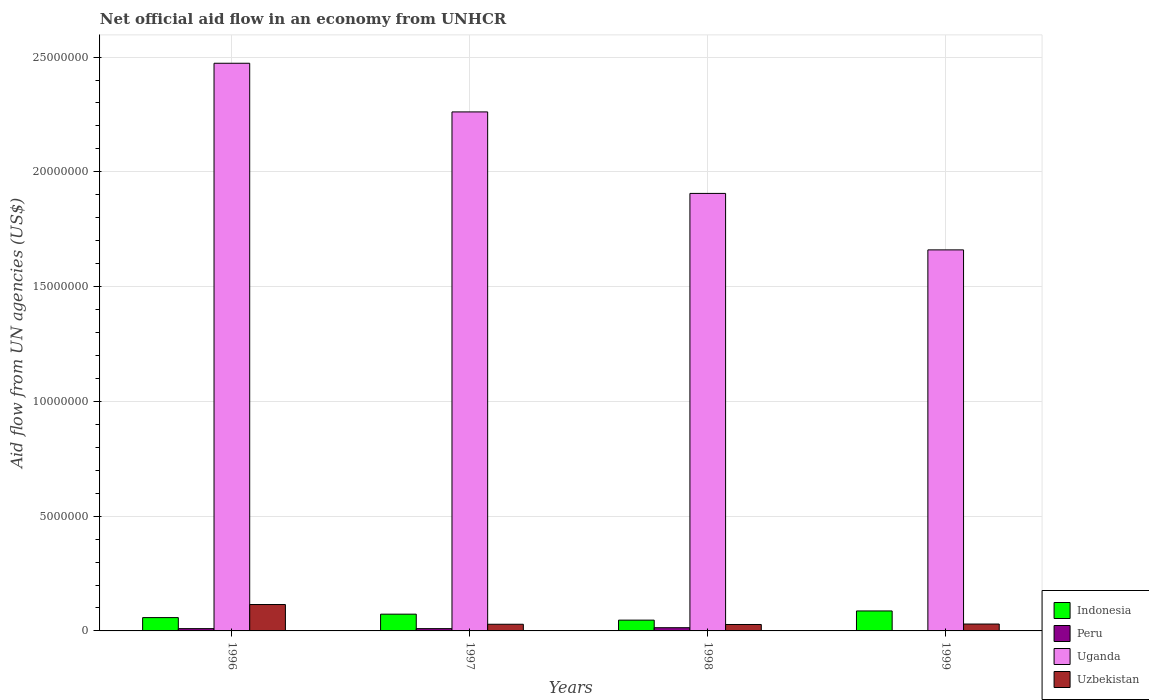How many different coloured bars are there?
Your answer should be compact. 4. How many groups of bars are there?
Your response must be concise. 4. Are the number of bars per tick equal to the number of legend labels?
Ensure brevity in your answer.  Yes. Are the number of bars on each tick of the X-axis equal?
Provide a succinct answer. Yes. How many bars are there on the 4th tick from the right?
Offer a terse response. 4. What is the net official aid flow in Uzbekistan in 1997?
Make the answer very short. 2.90e+05. Across all years, what is the minimum net official aid flow in Indonesia?
Offer a very short reply. 4.70e+05. In which year was the net official aid flow in Peru minimum?
Provide a short and direct response. 1999. What is the difference between the net official aid flow in Uzbekistan in 1996 and that in 1997?
Offer a very short reply. 8.60e+05. What is the difference between the net official aid flow in Peru in 1997 and the net official aid flow in Indonesia in 1996?
Make the answer very short. -4.80e+05. What is the average net official aid flow in Indonesia per year?
Make the answer very short. 6.62e+05. In the year 1997, what is the difference between the net official aid flow in Uzbekistan and net official aid flow in Indonesia?
Give a very brief answer. -4.40e+05. In how many years, is the net official aid flow in Uganda greater than 6000000 US$?
Provide a short and direct response. 4. What is the ratio of the net official aid flow in Indonesia in 1996 to that in 1998?
Make the answer very short. 1.23. Is the net official aid flow in Uzbekistan in 1996 less than that in 1998?
Offer a very short reply. No. Is the difference between the net official aid flow in Uzbekistan in 1997 and 1999 greater than the difference between the net official aid flow in Indonesia in 1997 and 1999?
Offer a very short reply. Yes. What is the difference between the highest and the second highest net official aid flow in Uzbekistan?
Make the answer very short. 8.50e+05. In how many years, is the net official aid flow in Uzbekistan greater than the average net official aid flow in Uzbekistan taken over all years?
Give a very brief answer. 1. Is the sum of the net official aid flow in Uzbekistan in 1996 and 1997 greater than the maximum net official aid flow in Peru across all years?
Provide a short and direct response. Yes. What does the 4th bar from the left in 1997 represents?
Make the answer very short. Uzbekistan. What does the 1st bar from the right in 1996 represents?
Give a very brief answer. Uzbekistan. Is it the case that in every year, the sum of the net official aid flow in Uganda and net official aid flow in Uzbekistan is greater than the net official aid flow in Indonesia?
Make the answer very short. Yes. Does the graph contain grids?
Provide a succinct answer. Yes. How are the legend labels stacked?
Offer a very short reply. Vertical. What is the title of the graph?
Your response must be concise. Net official aid flow in an economy from UNHCR. Does "Niger" appear as one of the legend labels in the graph?
Give a very brief answer. No. What is the label or title of the X-axis?
Your response must be concise. Years. What is the label or title of the Y-axis?
Give a very brief answer. Aid flow from UN agencies (US$). What is the Aid flow from UN agencies (US$) of Indonesia in 1996?
Provide a succinct answer. 5.80e+05. What is the Aid flow from UN agencies (US$) of Peru in 1996?
Keep it short and to the point. 1.00e+05. What is the Aid flow from UN agencies (US$) in Uganda in 1996?
Give a very brief answer. 2.47e+07. What is the Aid flow from UN agencies (US$) in Uzbekistan in 1996?
Keep it short and to the point. 1.15e+06. What is the Aid flow from UN agencies (US$) of Indonesia in 1997?
Keep it short and to the point. 7.30e+05. What is the Aid flow from UN agencies (US$) in Uganda in 1997?
Your answer should be very brief. 2.26e+07. What is the Aid flow from UN agencies (US$) of Uzbekistan in 1997?
Provide a short and direct response. 2.90e+05. What is the Aid flow from UN agencies (US$) of Uganda in 1998?
Ensure brevity in your answer.  1.91e+07. What is the Aid flow from UN agencies (US$) of Uzbekistan in 1998?
Give a very brief answer. 2.80e+05. What is the Aid flow from UN agencies (US$) of Indonesia in 1999?
Provide a succinct answer. 8.70e+05. What is the Aid flow from UN agencies (US$) in Peru in 1999?
Provide a succinct answer. 10000. What is the Aid flow from UN agencies (US$) in Uganda in 1999?
Give a very brief answer. 1.66e+07. Across all years, what is the maximum Aid flow from UN agencies (US$) of Indonesia?
Make the answer very short. 8.70e+05. Across all years, what is the maximum Aid flow from UN agencies (US$) of Peru?
Give a very brief answer. 1.40e+05. Across all years, what is the maximum Aid flow from UN agencies (US$) of Uganda?
Provide a succinct answer. 2.47e+07. Across all years, what is the maximum Aid flow from UN agencies (US$) in Uzbekistan?
Provide a short and direct response. 1.15e+06. Across all years, what is the minimum Aid flow from UN agencies (US$) in Indonesia?
Your response must be concise. 4.70e+05. Across all years, what is the minimum Aid flow from UN agencies (US$) in Peru?
Offer a very short reply. 10000. Across all years, what is the minimum Aid flow from UN agencies (US$) of Uganda?
Your response must be concise. 1.66e+07. What is the total Aid flow from UN agencies (US$) in Indonesia in the graph?
Keep it short and to the point. 2.65e+06. What is the total Aid flow from UN agencies (US$) in Peru in the graph?
Make the answer very short. 3.50e+05. What is the total Aid flow from UN agencies (US$) in Uganda in the graph?
Your answer should be compact. 8.30e+07. What is the total Aid flow from UN agencies (US$) in Uzbekistan in the graph?
Keep it short and to the point. 2.02e+06. What is the difference between the Aid flow from UN agencies (US$) in Peru in 1996 and that in 1997?
Give a very brief answer. 0. What is the difference between the Aid flow from UN agencies (US$) of Uganda in 1996 and that in 1997?
Your answer should be very brief. 2.12e+06. What is the difference between the Aid flow from UN agencies (US$) in Uzbekistan in 1996 and that in 1997?
Offer a terse response. 8.60e+05. What is the difference between the Aid flow from UN agencies (US$) of Uganda in 1996 and that in 1998?
Keep it short and to the point. 5.67e+06. What is the difference between the Aid flow from UN agencies (US$) of Uzbekistan in 1996 and that in 1998?
Give a very brief answer. 8.70e+05. What is the difference between the Aid flow from UN agencies (US$) of Uganda in 1996 and that in 1999?
Your answer should be very brief. 8.13e+06. What is the difference between the Aid flow from UN agencies (US$) of Uzbekistan in 1996 and that in 1999?
Keep it short and to the point. 8.50e+05. What is the difference between the Aid flow from UN agencies (US$) of Indonesia in 1997 and that in 1998?
Your answer should be very brief. 2.60e+05. What is the difference between the Aid flow from UN agencies (US$) in Peru in 1997 and that in 1998?
Your response must be concise. -4.00e+04. What is the difference between the Aid flow from UN agencies (US$) of Uganda in 1997 and that in 1998?
Your response must be concise. 3.55e+06. What is the difference between the Aid flow from UN agencies (US$) in Peru in 1997 and that in 1999?
Make the answer very short. 9.00e+04. What is the difference between the Aid flow from UN agencies (US$) of Uganda in 1997 and that in 1999?
Provide a short and direct response. 6.01e+06. What is the difference between the Aid flow from UN agencies (US$) of Uzbekistan in 1997 and that in 1999?
Your answer should be compact. -10000. What is the difference between the Aid flow from UN agencies (US$) in Indonesia in 1998 and that in 1999?
Your answer should be very brief. -4.00e+05. What is the difference between the Aid flow from UN agencies (US$) of Peru in 1998 and that in 1999?
Ensure brevity in your answer.  1.30e+05. What is the difference between the Aid flow from UN agencies (US$) in Uganda in 1998 and that in 1999?
Your answer should be compact. 2.46e+06. What is the difference between the Aid flow from UN agencies (US$) in Indonesia in 1996 and the Aid flow from UN agencies (US$) in Peru in 1997?
Provide a succinct answer. 4.80e+05. What is the difference between the Aid flow from UN agencies (US$) in Indonesia in 1996 and the Aid flow from UN agencies (US$) in Uganda in 1997?
Ensure brevity in your answer.  -2.20e+07. What is the difference between the Aid flow from UN agencies (US$) in Peru in 1996 and the Aid flow from UN agencies (US$) in Uganda in 1997?
Offer a terse response. -2.25e+07. What is the difference between the Aid flow from UN agencies (US$) in Uganda in 1996 and the Aid flow from UN agencies (US$) in Uzbekistan in 1997?
Keep it short and to the point. 2.44e+07. What is the difference between the Aid flow from UN agencies (US$) of Indonesia in 1996 and the Aid flow from UN agencies (US$) of Peru in 1998?
Offer a very short reply. 4.40e+05. What is the difference between the Aid flow from UN agencies (US$) in Indonesia in 1996 and the Aid flow from UN agencies (US$) in Uganda in 1998?
Give a very brief answer. -1.85e+07. What is the difference between the Aid flow from UN agencies (US$) in Indonesia in 1996 and the Aid flow from UN agencies (US$) in Uzbekistan in 1998?
Your answer should be compact. 3.00e+05. What is the difference between the Aid flow from UN agencies (US$) of Peru in 1996 and the Aid flow from UN agencies (US$) of Uganda in 1998?
Provide a short and direct response. -1.90e+07. What is the difference between the Aid flow from UN agencies (US$) of Uganda in 1996 and the Aid flow from UN agencies (US$) of Uzbekistan in 1998?
Offer a terse response. 2.44e+07. What is the difference between the Aid flow from UN agencies (US$) in Indonesia in 1996 and the Aid flow from UN agencies (US$) in Peru in 1999?
Provide a succinct answer. 5.70e+05. What is the difference between the Aid flow from UN agencies (US$) of Indonesia in 1996 and the Aid flow from UN agencies (US$) of Uganda in 1999?
Offer a very short reply. -1.60e+07. What is the difference between the Aid flow from UN agencies (US$) in Indonesia in 1996 and the Aid flow from UN agencies (US$) in Uzbekistan in 1999?
Ensure brevity in your answer.  2.80e+05. What is the difference between the Aid flow from UN agencies (US$) of Peru in 1996 and the Aid flow from UN agencies (US$) of Uganda in 1999?
Offer a very short reply. -1.65e+07. What is the difference between the Aid flow from UN agencies (US$) of Uganda in 1996 and the Aid flow from UN agencies (US$) of Uzbekistan in 1999?
Make the answer very short. 2.44e+07. What is the difference between the Aid flow from UN agencies (US$) in Indonesia in 1997 and the Aid flow from UN agencies (US$) in Peru in 1998?
Your answer should be compact. 5.90e+05. What is the difference between the Aid flow from UN agencies (US$) of Indonesia in 1997 and the Aid flow from UN agencies (US$) of Uganda in 1998?
Your answer should be very brief. -1.83e+07. What is the difference between the Aid flow from UN agencies (US$) of Peru in 1997 and the Aid flow from UN agencies (US$) of Uganda in 1998?
Offer a terse response. -1.90e+07. What is the difference between the Aid flow from UN agencies (US$) in Uganda in 1997 and the Aid flow from UN agencies (US$) in Uzbekistan in 1998?
Keep it short and to the point. 2.23e+07. What is the difference between the Aid flow from UN agencies (US$) in Indonesia in 1997 and the Aid flow from UN agencies (US$) in Peru in 1999?
Offer a very short reply. 7.20e+05. What is the difference between the Aid flow from UN agencies (US$) in Indonesia in 1997 and the Aid flow from UN agencies (US$) in Uganda in 1999?
Provide a short and direct response. -1.59e+07. What is the difference between the Aid flow from UN agencies (US$) in Indonesia in 1997 and the Aid flow from UN agencies (US$) in Uzbekistan in 1999?
Your answer should be very brief. 4.30e+05. What is the difference between the Aid flow from UN agencies (US$) of Peru in 1997 and the Aid flow from UN agencies (US$) of Uganda in 1999?
Provide a succinct answer. -1.65e+07. What is the difference between the Aid flow from UN agencies (US$) of Uganda in 1997 and the Aid flow from UN agencies (US$) of Uzbekistan in 1999?
Give a very brief answer. 2.23e+07. What is the difference between the Aid flow from UN agencies (US$) of Indonesia in 1998 and the Aid flow from UN agencies (US$) of Peru in 1999?
Offer a very short reply. 4.60e+05. What is the difference between the Aid flow from UN agencies (US$) in Indonesia in 1998 and the Aid flow from UN agencies (US$) in Uganda in 1999?
Your response must be concise. -1.61e+07. What is the difference between the Aid flow from UN agencies (US$) in Indonesia in 1998 and the Aid flow from UN agencies (US$) in Uzbekistan in 1999?
Ensure brevity in your answer.  1.70e+05. What is the difference between the Aid flow from UN agencies (US$) of Peru in 1998 and the Aid flow from UN agencies (US$) of Uganda in 1999?
Offer a very short reply. -1.65e+07. What is the difference between the Aid flow from UN agencies (US$) in Uganda in 1998 and the Aid flow from UN agencies (US$) in Uzbekistan in 1999?
Offer a very short reply. 1.88e+07. What is the average Aid flow from UN agencies (US$) of Indonesia per year?
Keep it short and to the point. 6.62e+05. What is the average Aid flow from UN agencies (US$) of Peru per year?
Make the answer very short. 8.75e+04. What is the average Aid flow from UN agencies (US$) in Uganda per year?
Ensure brevity in your answer.  2.08e+07. What is the average Aid flow from UN agencies (US$) in Uzbekistan per year?
Provide a succinct answer. 5.05e+05. In the year 1996, what is the difference between the Aid flow from UN agencies (US$) in Indonesia and Aid flow from UN agencies (US$) in Uganda?
Ensure brevity in your answer.  -2.42e+07. In the year 1996, what is the difference between the Aid flow from UN agencies (US$) in Indonesia and Aid flow from UN agencies (US$) in Uzbekistan?
Ensure brevity in your answer.  -5.70e+05. In the year 1996, what is the difference between the Aid flow from UN agencies (US$) in Peru and Aid flow from UN agencies (US$) in Uganda?
Provide a short and direct response. -2.46e+07. In the year 1996, what is the difference between the Aid flow from UN agencies (US$) of Peru and Aid flow from UN agencies (US$) of Uzbekistan?
Ensure brevity in your answer.  -1.05e+06. In the year 1996, what is the difference between the Aid flow from UN agencies (US$) of Uganda and Aid flow from UN agencies (US$) of Uzbekistan?
Provide a short and direct response. 2.36e+07. In the year 1997, what is the difference between the Aid flow from UN agencies (US$) of Indonesia and Aid flow from UN agencies (US$) of Peru?
Offer a very short reply. 6.30e+05. In the year 1997, what is the difference between the Aid flow from UN agencies (US$) in Indonesia and Aid flow from UN agencies (US$) in Uganda?
Make the answer very short. -2.19e+07. In the year 1997, what is the difference between the Aid flow from UN agencies (US$) of Peru and Aid flow from UN agencies (US$) of Uganda?
Your answer should be very brief. -2.25e+07. In the year 1997, what is the difference between the Aid flow from UN agencies (US$) in Uganda and Aid flow from UN agencies (US$) in Uzbekistan?
Ensure brevity in your answer.  2.23e+07. In the year 1998, what is the difference between the Aid flow from UN agencies (US$) of Indonesia and Aid flow from UN agencies (US$) of Peru?
Offer a terse response. 3.30e+05. In the year 1998, what is the difference between the Aid flow from UN agencies (US$) of Indonesia and Aid flow from UN agencies (US$) of Uganda?
Provide a succinct answer. -1.86e+07. In the year 1998, what is the difference between the Aid flow from UN agencies (US$) of Peru and Aid flow from UN agencies (US$) of Uganda?
Your answer should be very brief. -1.89e+07. In the year 1998, what is the difference between the Aid flow from UN agencies (US$) in Uganda and Aid flow from UN agencies (US$) in Uzbekistan?
Ensure brevity in your answer.  1.88e+07. In the year 1999, what is the difference between the Aid flow from UN agencies (US$) in Indonesia and Aid flow from UN agencies (US$) in Peru?
Give a very brief answer. 8.60e+05. In the year 1999, what is the difference between the Aid flow from UN agencies (US$) in Indonesia and Aid flow from UN agencies (US$) in Uganda?
Provide a short and direct response. -1.57e+07. In the year 1999, what is the difference between the Aid flow from UN agencies (US$) in Indonesia and Aid flow from UN agencies (US$) in Uzbekistan?
Your answer should be very brief. 5.70e+05. In the year 1999, what is the difference between the Aid flow from UN agencies (US$) in Peru and Aid flow from UN agencies (US$) in Uganda?
Your response must be concise. -1.66e+07. In the year 1999, what is the difference between the Aid flow from UN agencies (US$) in Peru and Aid flow from UN agencies (US$) in Uzbekistan?
Your answer should be very brief. -2.90e+05. In the year 1999, what is the difference between the Aid flow from UN agencies (US$) in Uganda and Aid flow from UN agencies (US$) in Uzbekistan?
Your answer should be very brief. 1.63e+07. What is the ratio of the Aid flow from UN agencies (US$) of Indonesia in 1996 to that in 1997?
Your answer should be very brief. 0.79. What is the ratio of the Aid flow from UN agencies (US$) in Uganda in 1996 to that in 1997?
Your response must be concise. 1.09. What is the ratio of the Aid flow from UN agencies (US$) of Uzbekistan in 1996 to that in 1997?
Your response must be concise. 3.97. What is the ratio of the Aid flow from UN agencies (US$) of Indonesia in 1996 to that in 1998?
Provide a short and direct response. 1.23. What is the ratio of the Aid flow from UN agencies (US$) of Peru in 1996 to that in 1998?
Provide a succinct answer. 0.71. What is the ratio of the Aid flow from UN agencies (US$) of Uganda in 1996 to that in 1998?
Your response must be concise. 1.3. What is the ratio of the Aid flow from UN agencies (US$) in Uzbekistan in 1996 to that in 1998?
Offer a very short reply. 4.11. What is the ratio of the Aid flow from UN agencies (US$) of Indonesia in 1996 to that in 1999?
Ensure brevity in your answer.  0.67. What is the ratio of the Aid flow from UN agencies (US$) of Peru in 1996 to that in 1999?
Your answer should be very brief. 10. What is the ratio of the Aid flow from UN agencies (US$) of Uganda in 1996 to that in 1999?
Provide a short and direct response. 1.49. What is the ratio of the Aid flow from UN agencies (US$) in Uzbekistan in 1996 to that in 1999?
Your answer should be very brief. 3.83. What is the ratio of the Aid flow from UN agencies (US$) of Indonesia in 1997 to that in 1998?
Your answer should be compact. 1.55. What is the ratio of the Aid flow from UN agencies (US$) of Peru in 1997 to that in 1998?
Your answer should be compact. 0.71. What is the ratio of the Aid flow from UN agencies (US$) of Uganda in 1997 to that in 1998?
Keep it short and to the point. 1.19. What is the ratio of the Aid flow from UN agencies (US$) in Uzbekistan in 1997 to that in 1998?
Make the answer very short. 1.04. What is the ratio of the Aid flow from UN agencies (US$) of Indonesia in 1997 to that in 1999?
Keep it short and to the point. 0.84. What is the ratio of the Aid flow from UN agencies (US$) of Peru in 1997 to that in 1999?
Keep it short and to the point. 10. What is the ratio of the Aid flow from UN agencies (US$) of Uganda in 1997 to that in 1999?
Offer a very short reply. 1.36. What is the ratio of the Aid flow from UN agencies (US$) in Uzbekistan in 1997 to that in 1999?
Give a very brief answer. 0.97. What is the ratio of the Aid flow from UN agencies (US$) in Indonesia in 1998 to that in 1999?
Your response must be concise. 0.54. What is the ratio of the Aid flow from UN agencies (US$) in Uganda in 1998 to that in 1999?
Your response must be concise. 1.15. What is the difference between the highest and the second highest Aid flow from UN agencies (US$) of Indonesia?
Your response must be concise. 1.40e+05. What is the difference between the highest and the second highest Aid flow from UN agencies (US$) of Peru?
Your answer should be compact. 4.00e+04. What is the difference between the highest and the second highest Aid flow from UN agencies (US$) of Uganda?
Make the answer very short. 2.12e+06. What is the difference between the highest and the second highest Aid flow from UN agencies (US$) of Uzbekistan?
Your response must be concise. 8.50e+05. What is the difference between the highest and the lowest Aid flow from UN agencies (US$) of Indonesia?
Make the answer very short. 4.00e+05. What is the difference between the highest and the lowest Aid flow from UN agencies (US$) of Uganda?
Offer a terse response. 8.13e+06. What is the difference between the highest and the lowest Aid flow from UN agencies (US$) of Uzbekistan?
Your response must be concise. 8.70e+05. 